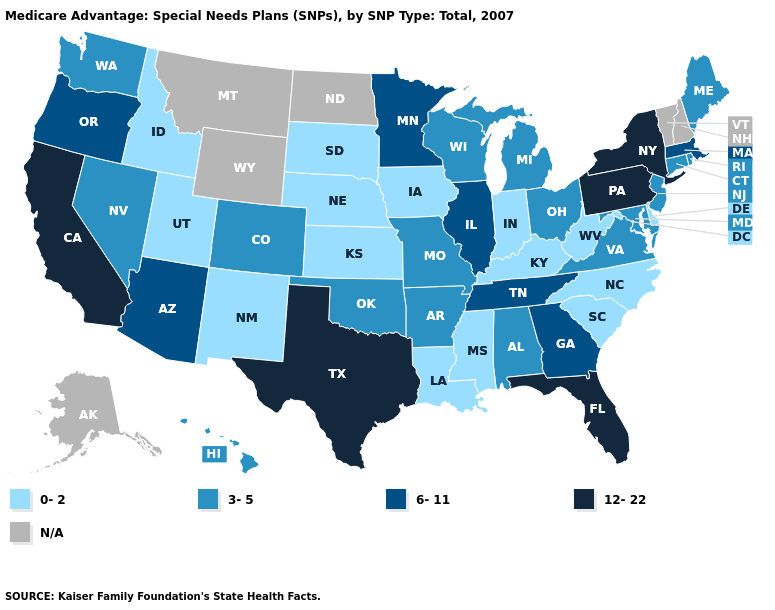What is the value of Nevada?
Write a very short answer. 3-5. What is the highest value in the USA?
Write a very short answer. 12-22. Does Tennessee have the highest value in the South?
Be succinct. No. What is the value of Massachusetts?
Short answer required. 6-11. What is the value of Idaho?
Give a very brief answer. 0-2. Does the first symbol in the legend represent the smallest category?
Write a very short answer. Yes. Does West Virginia have the lowest value in the South?
Write a very short answer. Yes. Among the states that border South Dakota , does Minnesota have the highest value?
Write a very short answer. Yes. What is the value of Maryland?
Concise answer only. 3-5. Does Mississippi have the lowest value in the USA?
Write a very short answer. Yes. Does Idaho have the highest value in the USA?
Quick response, please. No. Among the states that border Alabama , which have the lowest value?
Concise answer only. Mississippi. Which states have the lowest value in the West?
Quick response, please. Idaho, New Mexico, Utah. What is the value of Tennessee?
Concise answer only. 6-11. 